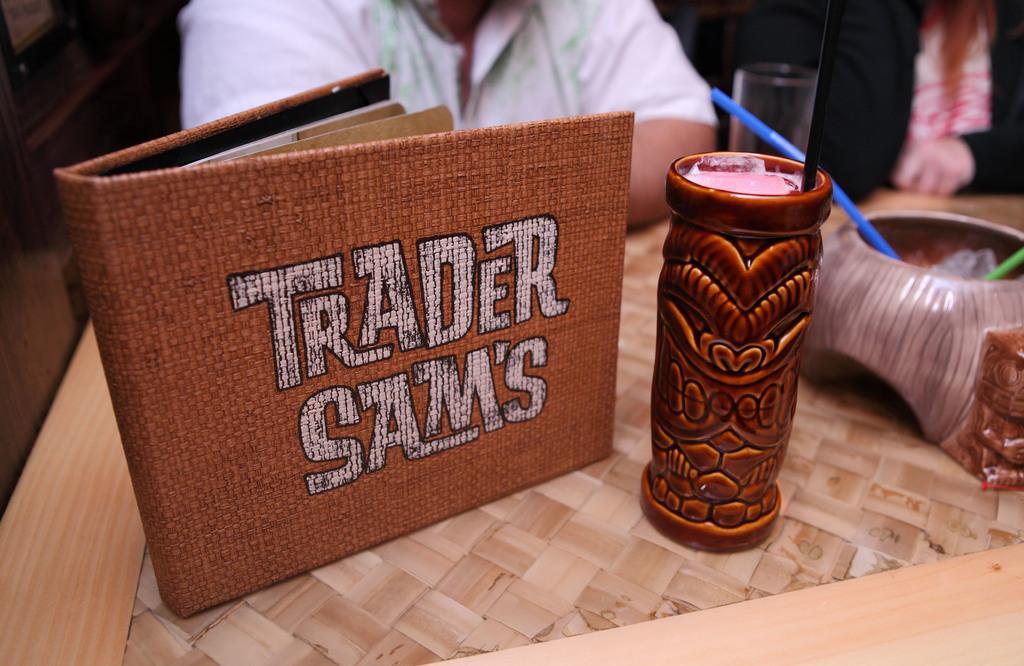Describe this image in one or two sentences. In this image there is a table towards the bottom of the image, there are objects on the table, there are glasses, there is the drink in the glass, there is a straw, there is a man towards the top of the image, there is a woman towards the top of the image. 